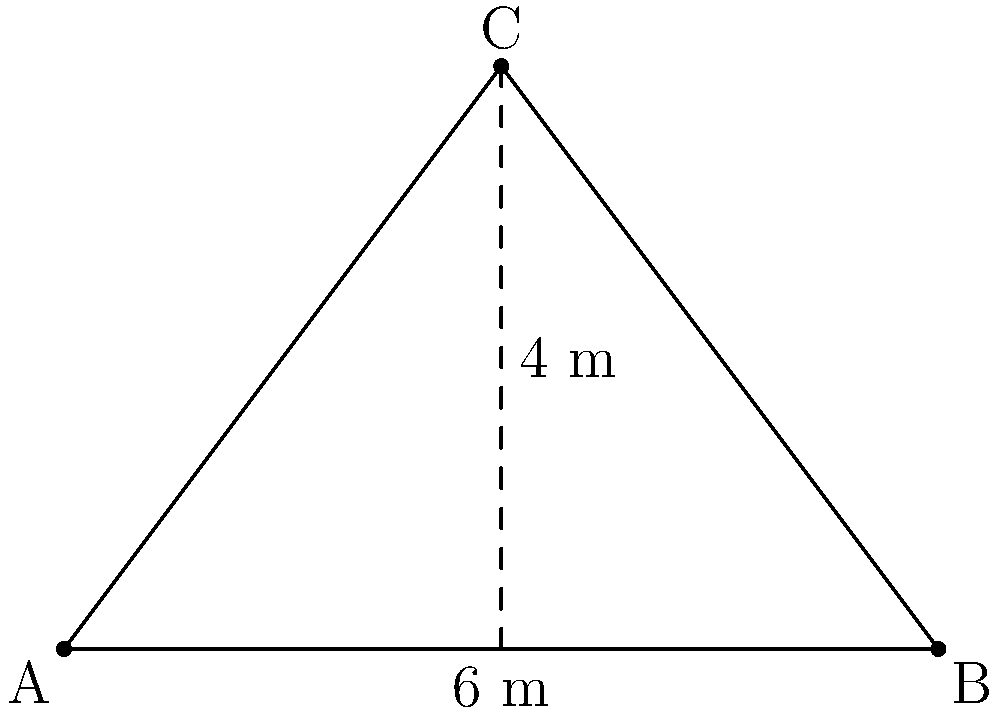In the diagram above, we see a triangular sail from an 18th-century frigate. The base of the sail measures 6 meters, and its height is 4 meters. What is the area of this sail in square meters? To find the area of a triangle given its base and height, we can use the formula:

$$A = \frac{1}{2} \times b \times h$$

Where:
$A$ = Area of the triangle
$b$ = Base of the triangle
$h$ = Height of the triangle

Given:
Base ($b$) = 6 meters
Height ($h$) = 4 meters

Let's substitute these values into the formula:

$$A = \frac{1}{2} \times 6 \times 4$$

$$A = \frac{1}{2} \times 24$$

$$A = 12$$

Therefore, the area of the triangular sail is 12 square meters.
Answer: 12 m² 